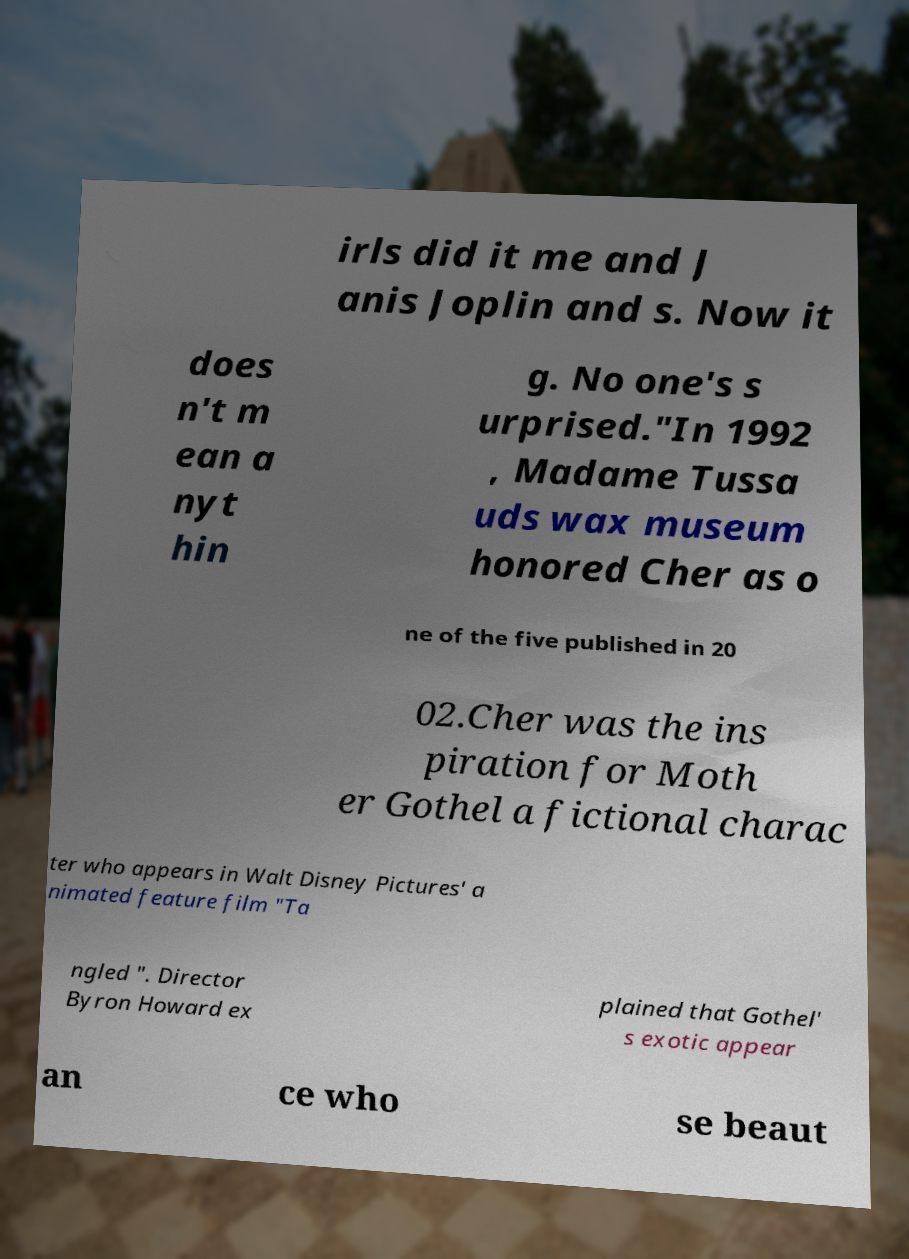Please identify and transcribe the text found in this image. irls did it me and J anis Joplin and s. Now it does n't m ean a nyt hin g. No one's s urprised."In 1992 , Madame Tussa uds wax museum honored Cher as o ne of the five published in 20 02.Cher was the ins piration for Moth er Gothel a fictional charac ter who appears in Walt Disney Pictures' a nimated feature film "Ta ngled ". Director Byron Howard ex plained that Gothel' s exotic appear an ce who se beaut 